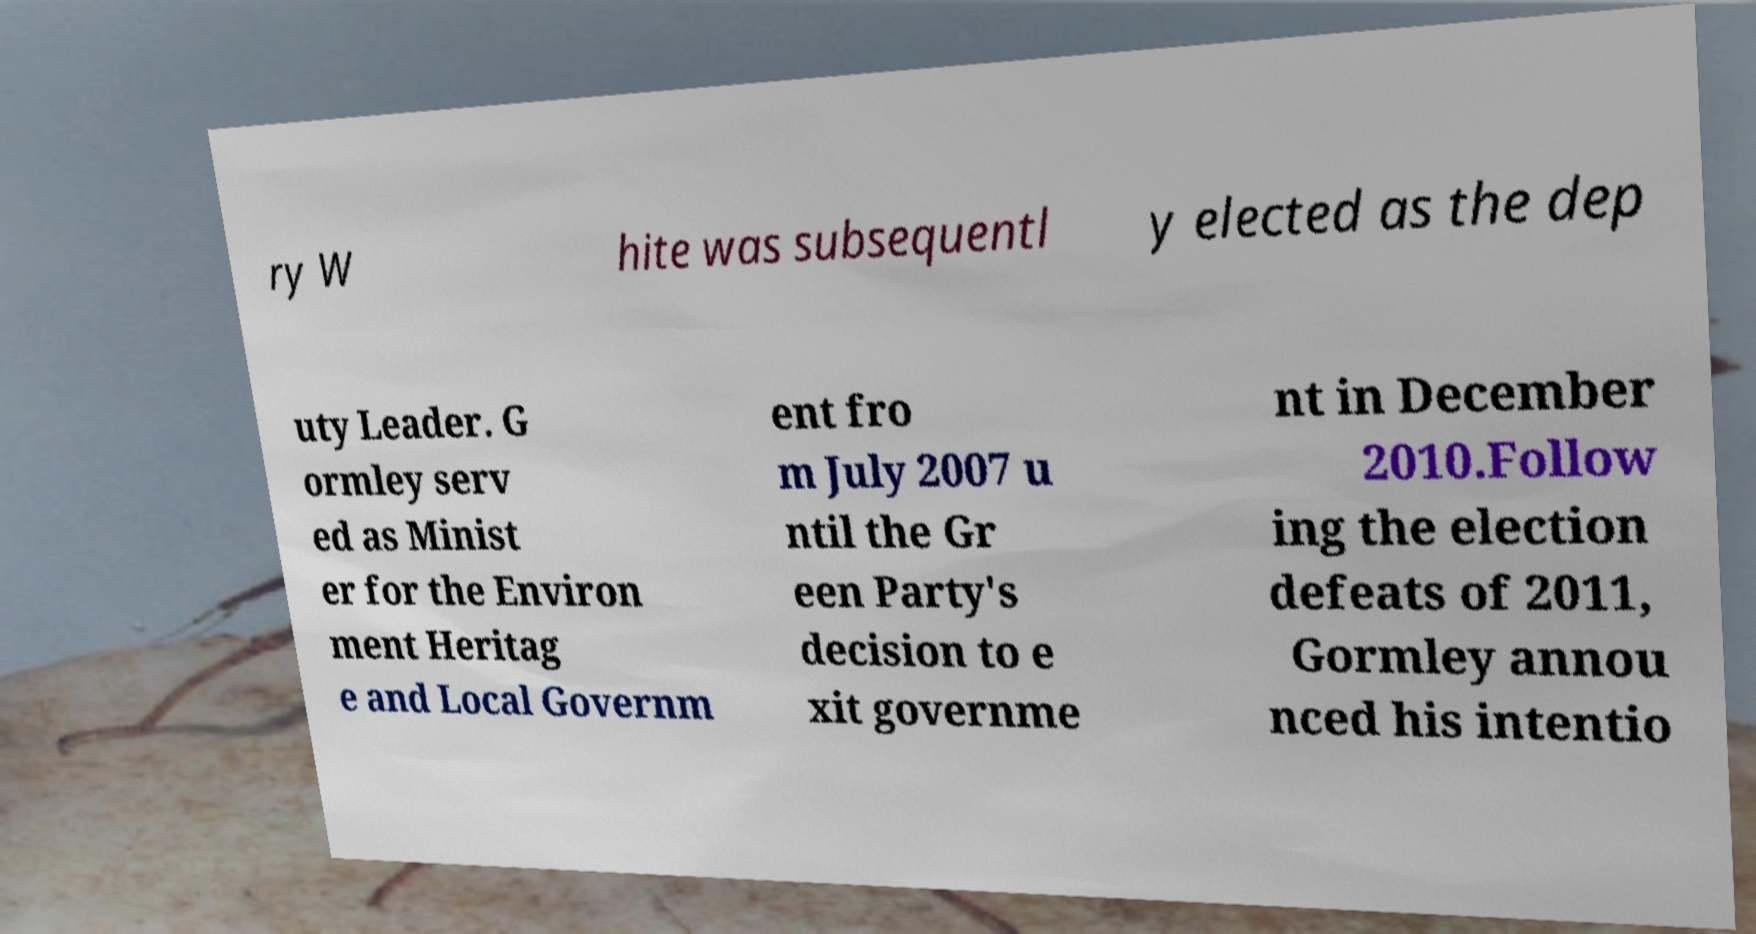Please read and relay the text visible in this image. What does it say? ry W hite was subsequentl y elected as the dep uty Leader. G ormley serv ed as Minist er for the Environ ment Heritag e and Local Governm ent fro m July 2007 u ntil the Gr een Party's decision to e xit governme nt in December 2010.Follow ing the election defeats of 2011, Gormley annou nced his intentio 